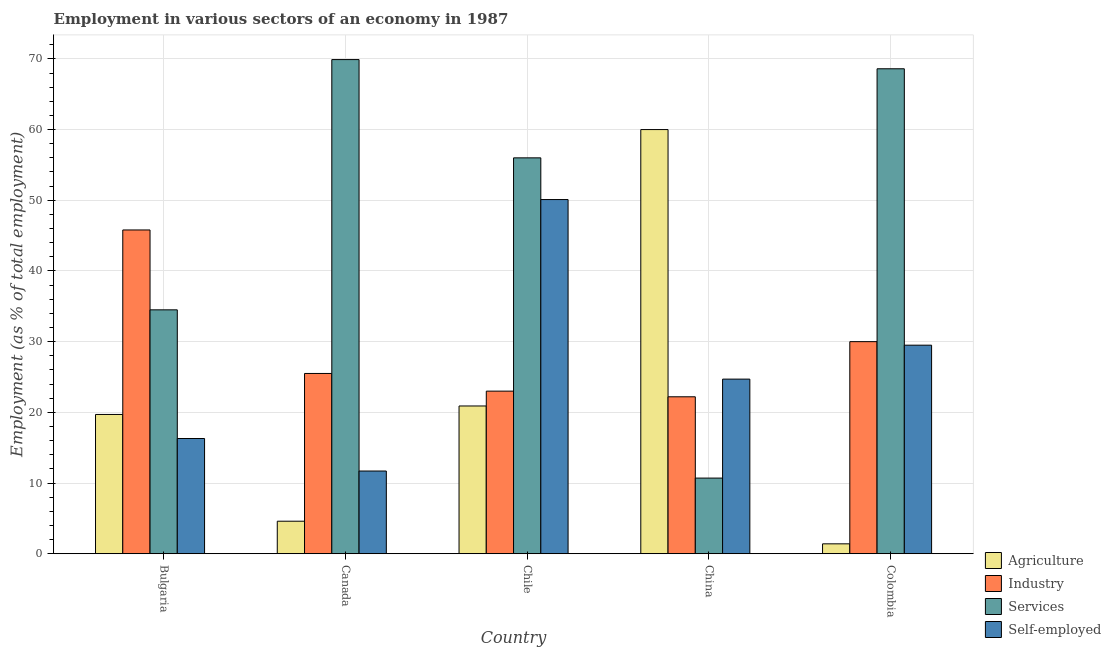How many different coloured bars are there?
Make the answer very short. 4. How many groups of bars are there?
Keep it short and to the point. 5. Are the number of bars on each tick of the X-axis equal?
Make the answer very short. Yes. What is the label of the 4th group of bars from the left?
Provide a short and direct response. China. Across all countries, what is the maximum percentage of self employed workers?
Your answer should be very brief. 50.1. Across all countries, what is the minimum percentage of workers in industry?
Keep it short and to the point. 22.2. In which country was the percentage of workers in agriculture maximum?
Your answer should be very brief. China. What is the total percentage of workers in services in the graph?
Give a very brief answer. 239.7. What is the difference between the percentage of workers in agriculture in Bulgaria and that in Canada?
Your response must be concise. 15.1. What is the difference between the percentage of workers in services in Chile and the percentage of workers in industry in Colombia?
Offer a very short reply. 26. What is the average percentage of workers in agriculture per country?
Ensure brevity in your answer.  21.32. What is the difference between the percentage of workers in agriculture and percentage of workers in industry in Bulgaria?
Offer a very short reply. -26.1. In how many countries, is the percentage of workers in services greater than 18 %?
Your answer should be very brief. 4. What is the ratio of the percentage of self employed workers in Bulgaria to that in China?
Provide a succinct answer. 0.66. What is the difference between the highest and the second highest percentage of workers in services?
Make the answer very short. 1.3. What is the difference between the highest and the lowest percentage of workers in services?
Offer a terse response. 59.2. In how many countries, is the percentage of workers in industry greater than the average percentage of workers in industry taken over all countries?
Provide a short and direct response. 2. Is it the case that in every country, the sum of the percentage of workers in services and percentage of workers in industry is greater than the sum of percentage of self employed workers and percentage of workers in agriculture?
Make the answer very short. No. What does the 2nd bar from the left in Canada represents?
Offer a terse response. Industry. What does the 4th bar from the right in Colombia represents?
Offer a very short reply. Agriculture. Is it the case that in every country, the sum of the percentage of workers in agriculture and percentage of workers in industry is greater than the percentage of workers in services?
Your response must be concise. No. Are the values on the major ticks of Y-axis written in scientific E-notation?
Give a very brief answer. No. Does the graph contain any zero values?
Give a very brief answer. No. Where does the legend appear in the graph?
Provide a succinct answer. Bottom right. How are the legend labels stacked?
Provide a succinct answer. Vertical. What is the title of the graph?
Your answer should be very brief. Employment in various sectors of an economy in 1987. Does "Taxes on revenue" appear as one of the legend labels in the graph?
Offer a terse response. No. What is the label or title of the X-axis?
Ensure brevity in your answer.  Country. What is the label or title of the Y-axis?
Offer a very short reply. Employment (as % of total employment). What is the Employment (as % of total employment) of Agriculture in Bulgaria?
Give a very brief answer. 19.7. What is the Employment (as % of total employment) of Industry in Bulgaria?
Make the answer very short. 45.8. What is the Employment (as % of total employment) in Services in Bulgaria?
Ensure brevity in your answer.  34.5. What is the Employment (as % of total employment) of Self-employed in Bulgaria?
Give a very brief answer. 16.3. What is the Employment (as % of total employment) of Agriculture in Canada?
Ensure brevity in your answer.  4.6. What is the Employment (as % of total employment) of Services in Canada?
Make the answer very short. 69.9. What is the Employment (as % of total employment) of Self-employed in Canada?
Your response must be concise. 11.7. What is the Employment (as % of total employment) in Agriculture in Chile?
Give a very brief answer. 20.9. What is the Employment (as % of total employment) in Self-employed in Chile?
Give a very brief answer. 50.1. What is the Employment (as % of total employment) of Agriculture in China?
Your answer should be very brief. 60. What is the Employment (as % of total employment) in Industry in China?
Your answer should be compact. 22.2. What is the Employment (as % of total employment) in Services in China?
Your answer should be compact. 10.7. What is the Employment (as % of total employment) of Self-employed in China?
Your response must be concise. 24.7. What is the Employment (as % of total employment) in Agriculture in Colombia?
Give a very brief answer. 1.4. What is the Employment (as % of total employment) of Services in Colombia?
Ensure brevity in your answer.  68.6. What is the Employment (as % of total employment) in Self-employed in Colombia?
Your answer should be compact. 29.5. Across all countries, what is the maximum Employment (as % of total employment) of Agriculture?
Make the answer very short. 60. Across all countries, what is the maximum Employment (as % of total employment) of Industry?
Your response must be concise. 45.8. Across all countries, what is the maximum Employment (as % of total employment) of Services?
Provide a succinct answer. 69.9. Across all countries, what is the maximum Employment (as % of total employment) of Self-employed?
Your answer should be very brief. 50.1. Across all countries, what is the minimum Employment (as % of total employment) of Agriculture?
Provide a succinct answer. 1.4. Across all countries, what is the minimum Employment (as % of total employment) in Industry?
Provide a short and direct response. 22.2. Across all countries, what is the minimum Employment (as % of total employment) of Services?
Offer a very short reply. 10.7. Across all countries, what is the minimum Employment (as % of total employment) of Self-employed?
Your response must be concise. 11.7. What is the total Employment (as % of total employment) in Agriculture in the graph?
Give a very brief answer. 106.6. What is the total Employment (as % of total employment) of Industry in the graph?
Keep it short and to the point. 146.5. What is the total Employment (as % of total employment) in Services in the graph?
Your answer should be very brief. 239.7. What is the total Employment (as % of total employment) of Self-employed in the graph?
Your response must be concise. 132.3. What is the difference between the Employment (as % of total employment) in Agriculture in Bulgaria and that in Canada?
Provide a short and direct response. 15.1. What is the difference between the Employment (as % of total employment) of Industry in Bulgaria and that in Canada?
Offer a terse response. 20.3. What is the difference between the Employment (as % of total employment) in Services in Bulgaria and that in Canada?
Provide a succinct answer. -35.4. What is the difference between the Employment (as % of total employment) of Industry in Bulgaria and that in Chile?
Provide a short and direct response. 22.8. What is the difference between the Employment (as % of total employment) of Services in Bulgaria and that in Chile?
Provide a short and direct response. -21.5. What is the difference between the Employment (as % of total employment) of Self-employed in Bulgaria and that in Chile?
Provide a succinct answer. -33.8. What is the difference between the Employment (as % of total employment) of Agriculture in Bulgaria and that in China?
Provide a short and direct response. -40.3. What is the difference between the Employment (as % of total employment) of Industry in Bulgaria and that in China?
Keep it short and to the point. 23.6. What is the difference between the Employment (as % of total employment) in Services in Bulgaria and that in China?
Your answer should be very brief. 23.8. What is the difference between the Employment (as % of total employment) of Industry in Bulgaria and that in Colombia?
Your answer should be compact. 15.8. What is the difference between the Employment (as % of total employment) in Services in Bulgaria and that in Colombia?
Keep it short and to the point. -34.1. What is the difference between the Employment (as % of total employment) in Self-employed in Bulgaria and that in Colombia?
Offer a very short reply. -13.2. What is the difference between the Employment (as % of total employment) in Agriculture in Canada and that in Chile?
Your answer should be compact. -16.3. What is the difference between the Employment (as % of total employment) of Industry in Canada and that in Chile?
Ensure brevity in your answer.  2.5. What is the difference between the Employment (as % of total employment) of Services in Canada and that in Chile?
Ensure brevity in your answer.  13.9. What is the difference between the Employment (as % of total employment) in Self-employed in Canada and that in Chile?
Give a very brief answer. -38.4. What is the difference between the Employment (as % of total employment) of Agriculture in Canada and that in China?
Ensure brevity in your answer.  -55.4. What is the difference between the Employment (as % of total employment) of Services in Canada and that in China?
Your response must be concise. 59.2. What is the difference between the Employment (as % of total employment) of Self-employed in Canada and that in China?
Provide a short and direct response. -13. What is the difference between the Employment (as % of total employment) of Agriculture in Canada and that in Colombia?
Give a very brief answer. 3.2. What is the difference between the Employment (as % of total employment) in Industry in Canada and that in Colombia?
Provide a short and direct response. -4.5. What is the difference between the Employment (as % of total employment) in Services in Canada and that in Colombia?
Ensure brevity in your answer.  1.3. What is the difference between the Employment (as % of total employment) in Self-employed in Canada and that in Colombia?
Offer a terse response. -17.8. What is the difference between the Employment (as % of total employment) of Agriculture in Chile and that in China?
Provide a short and direct response. -39.1. What is the difference between the Employment (as % of total employment) in Services in Chile and that in China?
Provide a short and direct response. 45.3. What is the difference between the Employment (as % of total employment) in Self-employed in Chile and that in China?
Your response must be concise. 25.4. What is the difference between the Employment (as % of total employment) in Self-employed in Chile and that in Colombia?
Your answer should be very brief. 20.6. What is the difference between the Employment (as % of total employment) in Agriculture in China and that in Colombia?
Your answer should be very brief. 58.6. What is the difference between the Employment (as % of total employment) of Services in China and that in Colombia?
Keep it short and to the point. -57.9. What is the difference between the Employment (as % of total employment) of Self-employed in China and that in Colombia?
Make the answer very short. -4.8. What is the difference between the Employment (as % of total employment) in Agriculture in Bulgaria and the Employment (as % of total employment) in Industry in Canada?
Your answer should be compact. -5.8. What is the difference between the Employment (as % of total employment) in Agriculture in Bulgaria and the Employment (as % of total employment) in Services in Canada?
Your answer should be compact. -50.2. What is the difference between the Employment (as % of total employment) of Agriculture in Bulgaria and the Employment (as % of total employment) of Self-employed in Canada?
Your answer should be very brief. 8. What is the difference between the Employment (as % of total employment) in Industry in Bulgaria and the Employment (as % of total employment) in Services in Canada?
Keep it short and to the point. -24.1. What is the difference between the Employment (as % of total employment) in Industry in Bulgaria and the Employment (as % of total employment) in Self-employed in Canada?
Your answer should be compact. 34.1. What is the difference between the Employment (as % of total employment) of Services in Bulgaria and the Employment (as % of total employment) of Self-employed in Canada?
Your answer should be compact. 22.8. What is the difference between the Employment (as % of total employment) in Agriculture in Bulgaria and the Employment (as % of total employment) in Services in Chile?
Your answer should be compact. -36.3. What is the difference between the Employment (as % of total employment) in Agriculture in Bulgaria and the Employment (as % of total employment) in Self-employed in Chile?
Make the answer very short. -30.4. What is the difference between the Employment (as % of total employment) in Services in Bulgaria and the Employment (as % of total employment) in Self-employed in Chile?
Your answer should be compact. -15.6. What is the difference between the Employment (as % of total employment) in Agriculture in Bulgaria and the Employment (as % of total employment) in Industry in China?
Make the answer very short. -2.5. What is the difference between the Employment (as % of total employment) of Agriculture in Bulgaria and the Employment (as % of total employment) of Services in China?
Your answer should be very brief. 9. What is the difference between the Employment (as % of total employment) of Industry in Bulgaria and the Employment (as % of total employment) of Services in China?
Offer a very short reply. 35.1. What is the difference between the Employment (as % of total employment) of Industry in Bulgaria and the Employment (as % of total employment) of Self-employed in China?
Keep it short and to the point. 21.1. What is the difference between the Employment (as % of total employment) in Services in Bulgaria and the Employment (as % of total employment) in Self-employed in China?
Your answer should be compact. 9.8. What is the difference between the Employment (as % of total employment) of Agriculture in Bulgaria and the Employment (as % of total employment) of Services in Colombia?
Offer a very short reply. -48.9. What is the difference between the Employment (as % of total employment) of Agriculture in Bulgaria and the Employment (as % of total employment) of Self-employed in Colombia?
Offer a terse response. -9.8. What is the difference between the Employment (as % of total employment) of Industry in Bulgaria and the Employment (as % of total employment) of Services in Colombia?
Give a very brief answer. -22.8. What is the difference between the Employment (as % of total employment) in Services in Bulgaria and the Employment (as % of total employment) in Self-employed in Colombia?
Provide a succinct answer. 5. What is the difference between the Employment (as % of total employment) in Agriculture in Canada and the Employment (as % of total employment) in Industry in Chile?
Give a very brief answer. -18.4. What is the difference between the Employment (as % of total employment) in Agriculture in Canada and the Employment (as % of total employment) in Services in Chile?
Provide a succinct answer. -51.4. What is the difference between the Employment (as % of total employment) in Agriculture in Canada and the Employment (as % of total employment) in Self-employed in Chile?
Your response must be concise. -45.5. What is the difference between the Employment (as % of total employment) of Industry in Canada and the Employment (as % of total employment) of Services in Chile?
Your answer should be compact. -30.5. What is the difference between the Employment (as % of total employment) in Industry in Canada and the Employment (as % of total employment) in Self-employed in Chile?
Offer a terse response. -24.6. What is the difference between the Employment (as % of total employment) of Services in Canada and the Employment (as % of total employment) of Self-employed in Chile?
Provide a short and direct response. 19.8. What is the difference between the Employment (as % of total employment) in Agriculture in Canada and the Employment (as % of total employment) in Industry in China?
Keep it short and to the point. -17.6. What is the difference between the Employment (as % of total employment) of Agriculture in Canada and the Employment (as % of total employment) of Self-employed in China?
Offer a terse response. -20.1. What is the difference between the Employment (as % of total employment) of Services in Canada and the Employment (as % of total employment) of Self-employed in China?
Provide a short and direct response. 45.2. What is the difference between the Employment (as % of total employment) in Agriculture in Canada and the Employment (as % of total employment) in Industry in Colombia?
Offer a terse response. -25.4. What is the difference between the Employment (as % of total employment) of Agriculture in Canada and the Employment (as % of total employment) of Services in Colombia?
Give a very brief answer. -64. What is the difference between the Employment (as % of total employment) in Agriculture in Canada and the Employment (as % of total employment) in Self-employed in Colombia?
Provide a short and direct response. -24.9. What is the difference between the Employment (as % of total employment) in Industry in Canada and the Employment (as % of total employment) in Services in Colombia?
Make the answer very short. -43.1. What is the difference between the Employment (as % of total employment) in Industry in Canada and the Employment (as % of total employment) in Self-employed in Colombia?
Ensure brevity in your answer.  -4. What is the difference between the Employment (as % of total employment) of Services in Canada and the Employment (as % of total employment) of Self-employed in Colombia?
Offer a terse response. 40.4. What is the difference between the Employment (as % of total employment) in Agriculture in Chile and the Employment (as % of total employment) in Services in China?
Your answer should be very brief. 10.2. What is the difference between the Employment (as % of total employment) of Agriculture in Chile and the Employment (as % of total employment) of Self-employed in China?
Your answer should be compact. -3.8. What is the difference between the Employment (as % of total employment) in Services in Chile and the Employment (as % of total employment) in Self-employed in China?
Your answer should be compact. 31.3. What is the difference between the Employment (as % of total employment) in Agriculture in Chile and the Employment (as % of total employment) in Services in Colombia?
Offer a terse response. -47.7. What is the difference between the Employment (as % of total employment) in Industry in Chile and the Employment (as % of total employment) in Services in Colombia?
Your answer should be compact. -45.6. What is the difference between the Employment (as % of total employment) in Services in Chile and the Employment (as % of total employment) in Self-employed in Colombia?
Your answer should be compact. 26.5. What is the difference between the Employment (as % of total employment) of Agriculture in China and the Employment (as % of total employment) of Services in Colombia?
Give a very brief answer. -8.6. What is the difference between the Employment (as % of total employment) of Agriculture in China and the Employment (as % of total employment) of Self-employed in Colombia?
Offer a very short reply. 30.5. What is the difference between the Employment (as % of total employment) in Industry in China and the Employment (as % of total employment) in Services in Colombia?
Your answer should be compact. -46.4. What is the difference between the Employment (as % of total employment) in Services in China and the Employment (as % of total employment) in Self-employed in Colombia?
Provide a succinct answer. -18.8. What is the average Employment (as % of total employment) in Agriculture per country?
Your answer should be compact. 21.32. What is the average Employment (as % of total employment) of Industry per country?
Give a very brief answer. 29.3. What is the average Employment (as % of total employment) in Services per country?
Your response must be concise. 47.94. What is the average Employment (as % of total employment) in Self-employed per country?
Keep it short and to the point. 26.46. What is the difference between the Employment (as % of total employment) of Agriculture and Employment (as % of total employment) of Industry in Bulgaria?
Give a very brief answer. -26.1. What is the difference between the Employment (as % of total employment) of Agriculture and Employment (as % of total employment) of Services in Bulgaria?
Make the answer very short. -14.8. What is the difference between the Employment (as % of total employment) in Agriculture and Employment (as % of total employment) in Self-employed in Bulgaria?
Keep it short and to the point. 3.4. What is the difference between the Employment (as % of total employment) of Industry and Employment (as % of total employment) of Self-employed in Bulgaria?
Offer a terse response. 29.5. What is the difference between the Employment (as % of total employment) of Services and Employment (as % of total employment) of Self-employed in Bulgaria?
Your answer should be compact. 18.2. What is the difference between the Employment (as % of total employment) in Agriculture and Employment (as % of total employment) in Industry in Canada?
Offer a terse response. -20.9. What is the difference between the Employment (as % of total employment) of Agriculture and Employment (as % of total employment) of Services in Canada?
Offer a terse response. -65.3. What is the difference between the Employment (as % of total employment) in Industry and Employment (as % of total employment) in Services in Canada?
Give a very brief answer. -44.4. What is the difference between the Employment (as % of total employment) in Services and Employment (as % of total employment) in Self-employed in Canada?
Ensure brevity in your answer.  58.2. What is the difference between the Employment (as % of total employment) of Agriculture and Employment (as % of total employment) of Industry in Chile?
Make the answer very short. -2.1. What is the difference between the Employment (as % of total employment) of Agriculture and Employment (as % of total employment) of Services in Chile?
Ensure brevity in your answer.  -35.1. What is the difference between the Employment (as % of total employment) in Agriculture and Employment (as % of total employment) in Self-employed in Chile?
Provide a short and direct response. -29.2. What is the difference between the Employment (as % of total employment) in Industry and Employment (as % of total employment) in Services in Chile?
Keep it short and to the point. -33. What is the difference between the Employment (as % of total employment) in Industry and Employment (as % of total employment) in Self-employed in Chile?
Keep it short and to the point. -27.1. What is the difference between the Employment (as % of total employment) in Services and Employment (as % of total employment) in Self-employed in Chile?
Your answer should be compact. 5.9. What is the difference between the Employment (as % of total employment) in Agriculture and Employment (as % of total employment) in Industry in China?
Provide a succinct answer. 37.8. What is the difference between the Employment (as % of total employment) of Agriculture and Employment (as % of total employment) of Services in China?
Your answer should be compact. 49.3. What is the difference between the Employment (as % of total employment) of Agriculture and Employment (as % of total employment) of Self-employed in China?
Keep it short and to the point. 35.3. What is the difference between the Employment (as % of total employment) of Industry and Employment (as % of total employment) of Services in China?
Make the answer very short. 11.5. What is the difference between the Employment (as % of total employment) of Agriculture and Employment (as % of total employment) of Industry in Colombia?
Offer a very short reply. -28.6. What is the difference between the Employment (as % of total employment) in Agriculture and Employment (as % of total employment) in Services in Colombia?
Make the answer very short. -67.2. What is the difference between the Employment (as % of total employment) in Agriculture and Employment (as % of total employment) in Self-employed in Colombia?
Provide a short and direct response. -28.1. What is the difference between the Employment (as % of total employment) in Industry and Employment (as % of total employment) in Services in Colombia?
Your answer should be compact. -38.6. What is the difference between the Employment (as % of total employment) in Services and Employment (as % of total employment) in Self-employed in Colombia?
Your answer should be very brief. 39.1. What is the ratio of the Employment (as % of total employment) of Agriculture in Bulgaria to that in Canada?
Your answer should be compact. 4.28. What is the ratio of the Employment (as % of total employment) of Industry in Bulgaria to that in Canada?
Ensure brevity in your answer.  1.8. What is the ratio of the Employment (as % of total employment) of Services in Bulgaria to that in Canada?
Your answer should be compact. 0.49. What is the ratio of the Employment (as % of total employment) of Self-employed in Bulgaria to that in Canada?
Your answer should be very brief. 1.39. What is the ratio of the Employment (as % of total employment) of Agriculture in Bulgaria to that in Chile?
Your answer should be very brief. 0.94. What is the ratio of the Employment (as % of total employment) of Industry in Bulgaria to that in Chile?
Give a very brief answer. 1.99. What is the ratio of the Employment (as % of total employment) of Services in Bulgaria to that in Chile?
Offer a terse response. 0.62. What is the ratio of the Employment (as % of total employment) of Self-employed in Bulgaria to that in Chile?
Give a very brief answer. 0.33. What is the ratio of the Employment (as % of total employment) in Agriculture in Bulgaria to that in China?
Your answer should be very brief. 0.33. What is the ratio of the Employment (as % of total employment) of Industry in Bulgaria to that in China?
Make the answer very short. 2.06. What is the ratio of the Employment (as % of total employment) in Services in Bulgaria to that in China?
Make the answer very short. 3.22. What is the ratio of the Employment (as % of total employment) in Self-employed in Bulgaria to that in China?
Your response must be concise. 0.66. What is the ratio of the Employment (as % of total employment) of Agriculture in Bulgaria to that in Colombia?
Give a very brief answer. 14.07. What is the ratio of the Employment (as % of total employment) in Industry in Bulgaria to that in Colombia?
Give a very brief answer. 1.53. What is the ratio of the Employment (as % of total employment) of Services in Bulgaria to that in Colombia?
Provide a succinct answer. 0.5. What is the ratio of the Employment (as % of total employment) in Self-employed in Bulgaria to that in Colombia?
Provide a short and direct response. 0.55. What is the ratio of the Employment (as % of total employment) in Agriculture in Canada to that in Chile?
Provide a succinct answer. 0.22. What is the ratio of the Employment (as % of total employment) of Industry in Canada to that in Chile?
Your answer should be compact. 1.11. What is the ratio of the Employment (as % of total employment) of Services in Canada to that in Chile?
Your response must be concise. 1.25. What is the ratio of the Employment (as % of total employment) in Self-employed in Canada to that in Chile?
Provide a succinct answer. 0.23. What is the ratio of the Employment (as % of total employment) of Agriculture in Canada to that in China?
Offer a terse response. 0.08. What is the ratio of the Employment (as % of total employment) of Industry in Canada to that in China?
Your answer should be compact. 1.15. What is the ratio of the Employment (as % of total employment) in Services in Canada to that in China?
Your answer should be compact. 6.53. What is the ratio of the Employment (as % of total employment) of Self-employed in Canada to that in China?
Offer a terse response. 0.47. What is the ratio of the Employment (as % of total employment) of Agriculture in Canada to that in Colombia?
Offer a terse response. 3.29. What is the ratio of the Employment (as % of total employment) in Self-employed in Canada to that in Colombia?
Ensure brevity in your answer.  0.4. What is the ratio of the Employment (as % of total employment) in Agriculture in Chile to that in China?
Keep it short and to the point. 0.35. What is the ratio of the Employment (as % of total employment) of Industry in Chile to that in China?
Your response must be concise. 1.04. What is the ratio of the Employment (as % of total employment) of Services in Chile to that in China?
Make the answer very short. 5.23. What is the ratio of the Employment (as % of total employment) in Self-employed in Chile to that in China?
Make the answer very short. 2.03. What is the ratio of the Employment (as % of total employment) in Agriculture in Chile to that in Colombia?
Provide a succinct answer. 14.93. What is the ratio of the Employment (as % of total employment) of Industry in Chile to that in Colombia?
Offer a terse response. 0.77. What is the ratio of the Employment (as % of total employment) of Services in Chile to that in Colombia?
Provide a succinct answer. 0.82. What is the ratio of the Employment (as % of total employment) in Self-employed in Chile to that in Colombia?
Your response must be concise. 1.7. What is the ratio of the Employment (as % of total employment) in Agriculture in China to that in Colombia?
Keep it short and to the point. 42.86. What is the ratio of the Employment (as % of total employment) of Industry in China to that in Colombia?
Provide a succinct answer. 0.74. What is the ratio of the Employment (as % of total employment) in Services in China to that in Colombia?
Provide a short and direct response. 0.16. What is the ratio of the Employment (as % of total employment) in Self-employed in China to that in Colombia?
Ensure brevity in your answer.  0.84. What is the difference between the highest and the second highest Employment (as % of total employment) of Agriculture?
Give a very brief answer. 39.1. What is the difference between the highest and the second highest Employment (as % of total employment) in Self-employed?
Your response must be concise. 20.6. What is the difference between the highest and the lowest Employment (as % of total employment) of Agriculture?
Keep it short and to the point. 58.6. What is the difference between the highest and the lowest Employment (as % of total employment) in Industry?
Offer a terse response. 23.6. What is the difference between the highest and the lowest Employment (as % of total employment) of Services?
Keep it short and to the point. 59.2. What is the difference between the highest and the lowest Employment (as % of total employment) of Self-employed?
Make the answer very short. 38.4. 